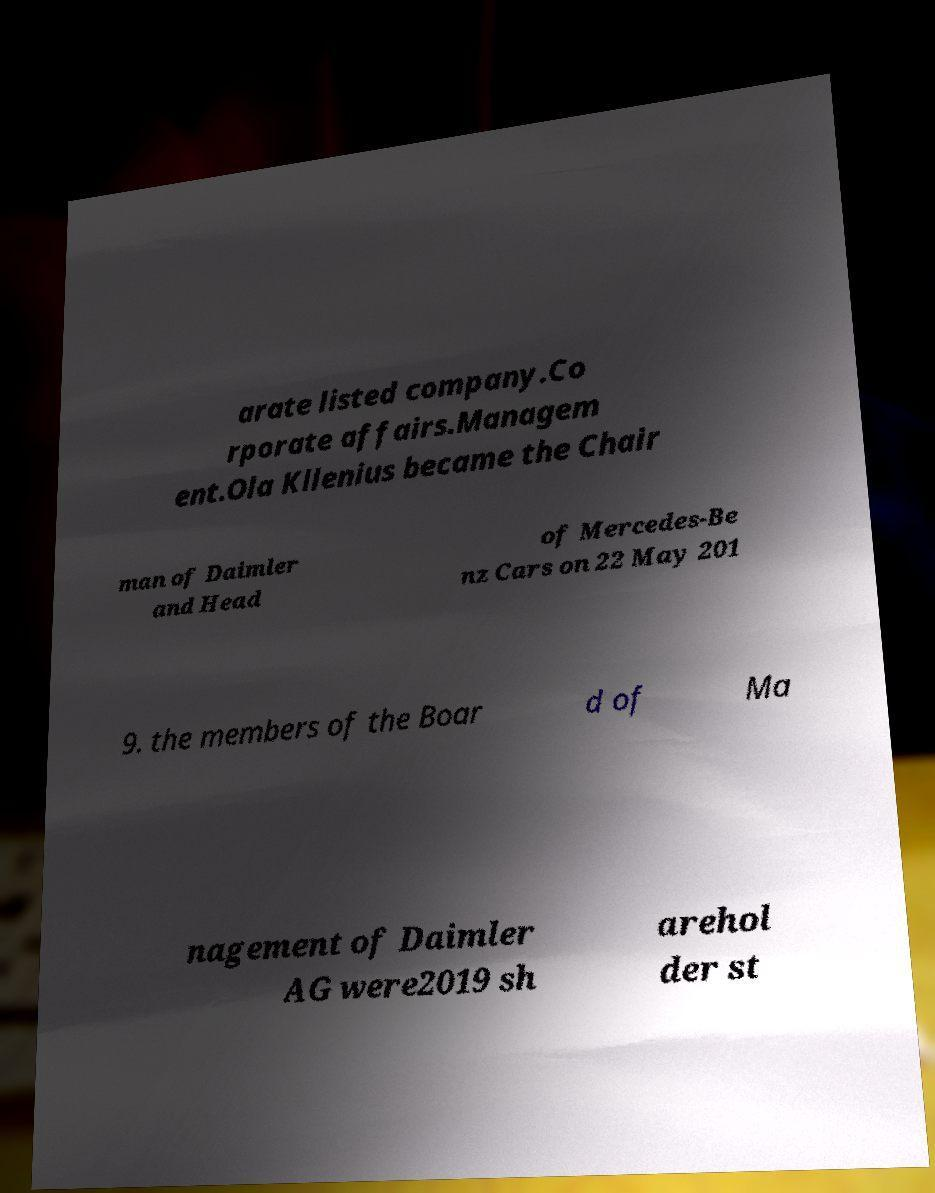Please read and relay the text visible in this image. What does it say? arate listed company.Co rporate affairs.Managem ent.Ola Kllenius became the Chair man of Daimler and Head of Mercedes-Be nz Cars on 22 May 201 9. the members of the Boar d of Ma nagement of Daimler AG were2019 sh arehol der st 